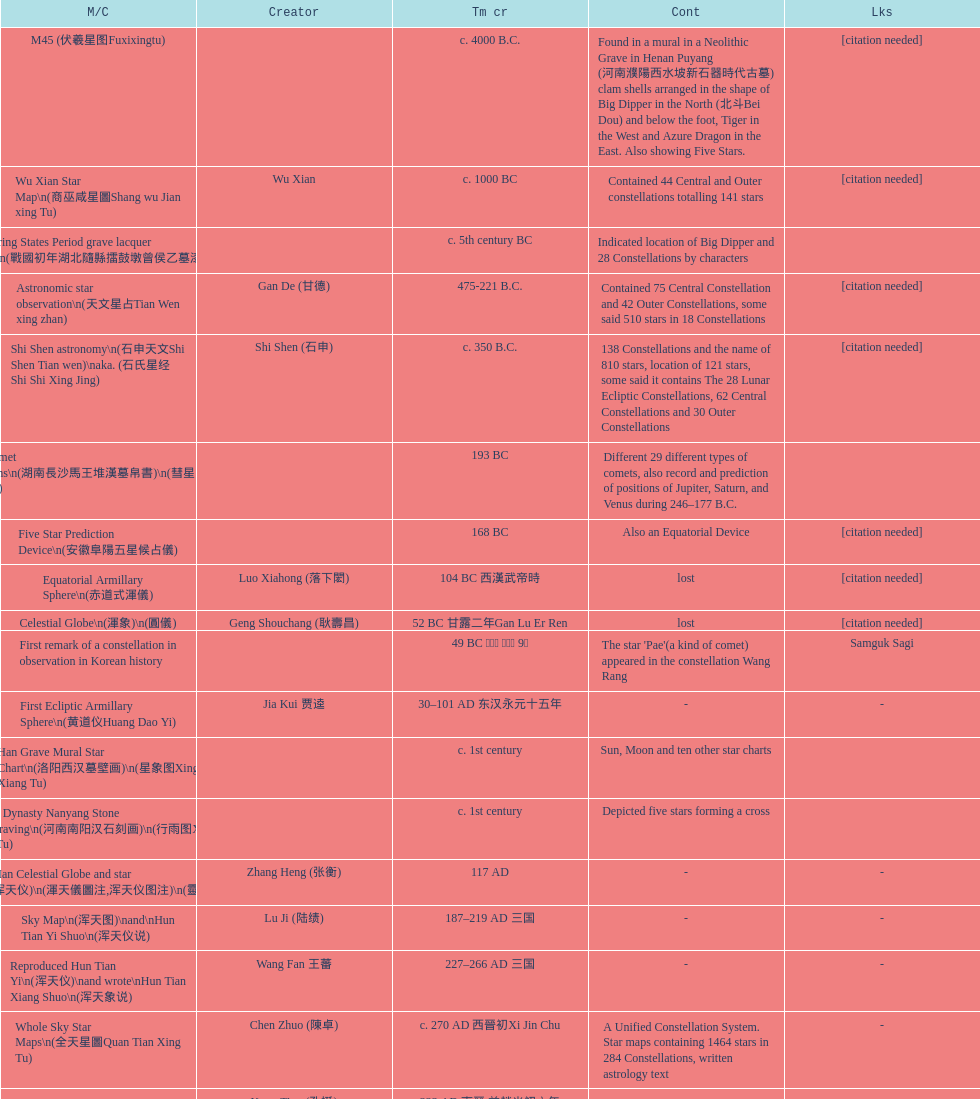At what point in time was the first map or catalog made? C. 4000 b.c. 